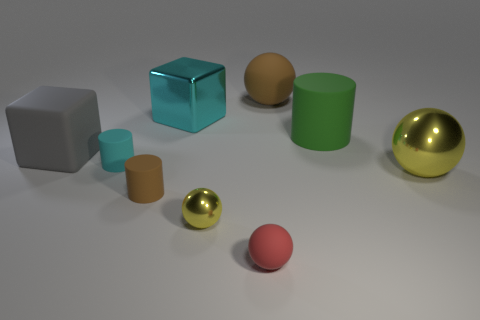What number of other things are the same size as the red rubber object?
Your answer should be very brief. 3. How many objects are right of the ball left of the red thing?
Keep it short and to the point. 4. Is the number of small metal balls that are behind the big matte ball less than the number of large gray matte objects?
Your answer should be very brief. Yes. There is a metallic object in front of the yellow metallic object that is right of the matte object that is right of the big matte sphere; what is its shape?
Offer a very short reply. Sphere. Is the shape of the tiny cyan thing the same as the large yellow thing?
Offer a terse response. No. How many other objects are there of the same shape as the gray matte object?
Provide a succinct answer. 1. There is another metallic cube that is the same size as the gray cube; what color is it?
Provide a succinct answer. Cyan. Are there an equal number of tiny red matte objects that are behind the cyan metallic thing and large blue things?
Make the answer very short. Yes. What shape is the shiny object that is both left of the red rubber sphere and in front of the big rubber cylinder?
Give a very brief answer. Sphere. Is the green matte thing the same size as the shiny block?
Ensure brevity in your answer.  Yes. 